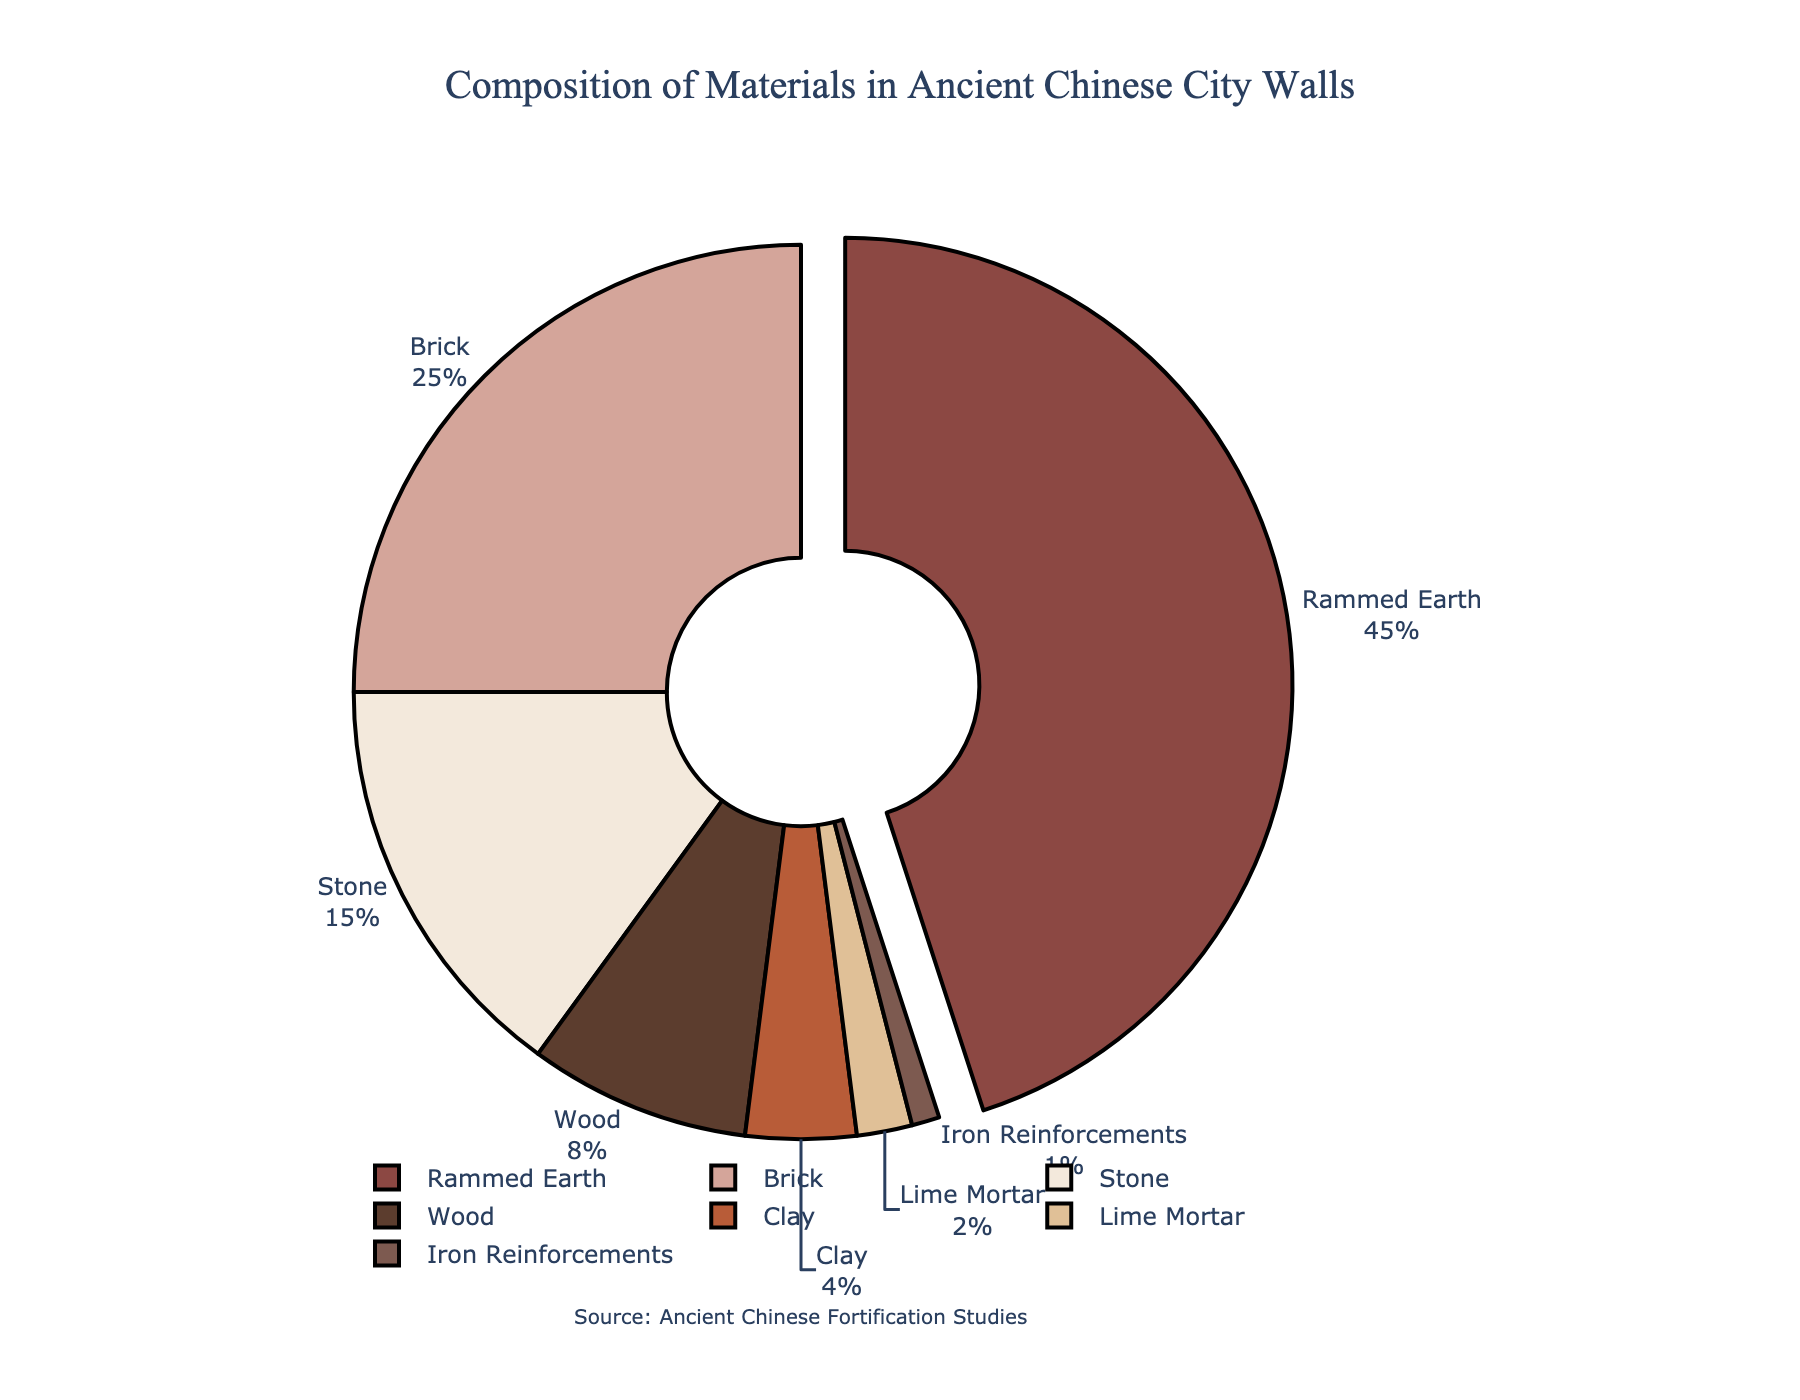What material makes up the largest portion of the ancient Chinese city walls? The largest portion of the pie chart is pulled out and labeled with 45%. This label corresponds to Rammed Earth.
Answer: Rammed Earth Which materials together make up more than half of the composition? Rammed Earth is 45% and Brick is 25%. Adding these two together: 45% + 25% = 70%, which is more than 50%.
Answer: Rammed Earth and Brick What is the percentage difference between Stone and Wood? Stone is 15% and Wood is 8%. Subtract 8% from 15% to find the percentage difference. 15% - 8% = 7%.
Answer: 7% How many materials make up less than 5% each of the composition? The materials with less than 5% are Clay (4%), Lime Mortar (2%), and Iron Reinforcements (1%). This is a total of 3 materials.
Answer: 3 Is Rammed Earth more than double the percentage of Stone? Rammed Earth is 45% and Stone is 15%. Double the percentage of Stone is 15% * 2 = 30%. 45% is indeed more than 30%, so Rammed Earth is more than double the percentage of Stone.
Answer: Yes Between Stone and Wood, which material is used more and by what percentage? Stone is used at 15% and Wood at 8%. Stone is used more. Subtract 8% from 15% to get the percentage difference: 15% - 8% = 7%.
Answer: Stone, by 7% If you combine Lime Mortar and Iron Reinforcements, what percentage of the composition do they make up? Lime Mortar is 2% and Iron Reinforcements are 1%. Adding these together: 2% + 1% = 3%.
Answer: 3% Which two materials together amount to exactly 12% of the composition? Wood is 8% and Clay is 4%. Adding these together: 8% + 4% = 12%.
Answer: Wood and Clay How much greater is the percentage of Brick than the sum of Iron Reinforcements and Lime Mortar? Brick is 25%, Iron Reinforcements are 1%, and Lime Mortar is 2%. Sum of Iron Reinforcements and Lime Mortar is 1% + 2% = 3%. Subtract 3% from 25%: 25% - 3% = 22%.
Answer: 22% What is the combined percentage for all materials except Rammed Earth? Rammed Earth is 45%, the total is 100%. Subtract 45% from 100% to find the combined percentage of other materials: 100% - 45% = 55%.
Answer: 55% 